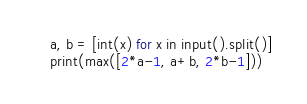Convert code to text. <code><loc_0><loc_0><loc_500><loc_500><_Python_>a, b = [int(x) for x in input().split()]
print(max([2*a-1, a+b, 2*b-1]))</code> 